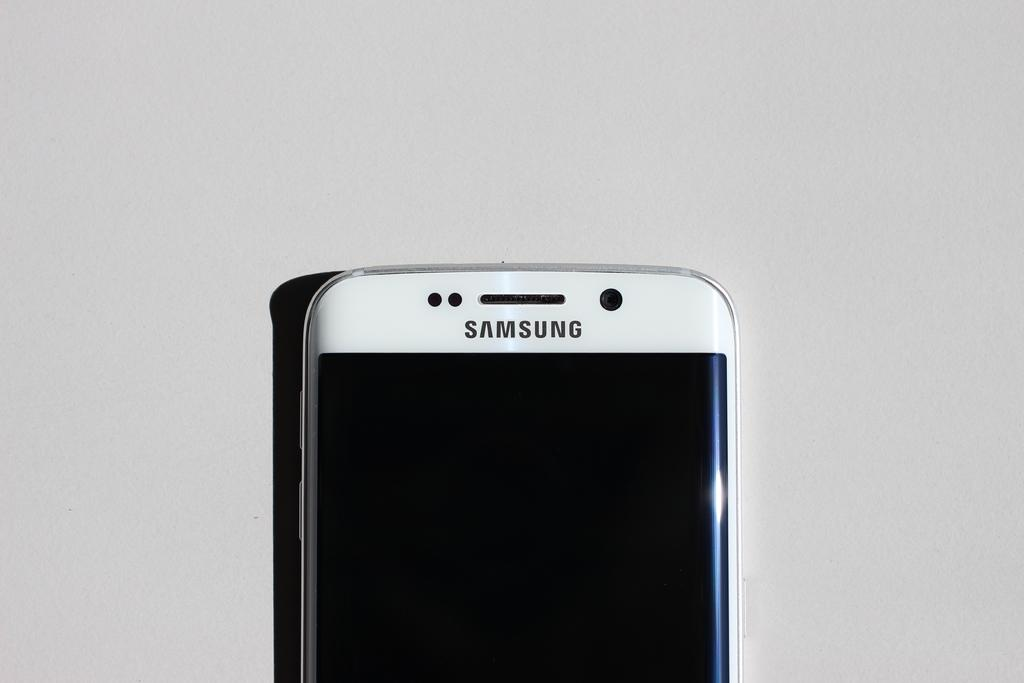<image>
Write a terse but informative summary of the picture. A Samsung brand phone sits on a table. 